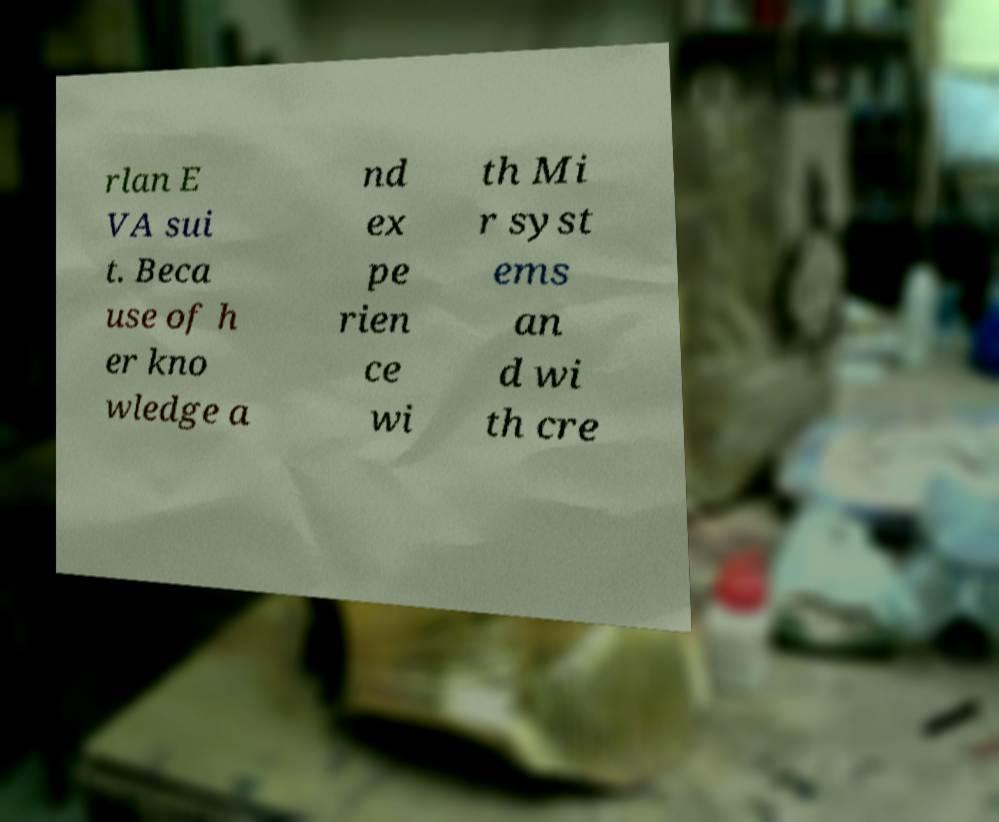There's text embedded in this image that I need extracted. Can you transcribe it verbatim? rlan E VA sui t. Beca use of h er kno wledge a nd ex pe rien ce wi th Mi r syst ems an d wi th cre 